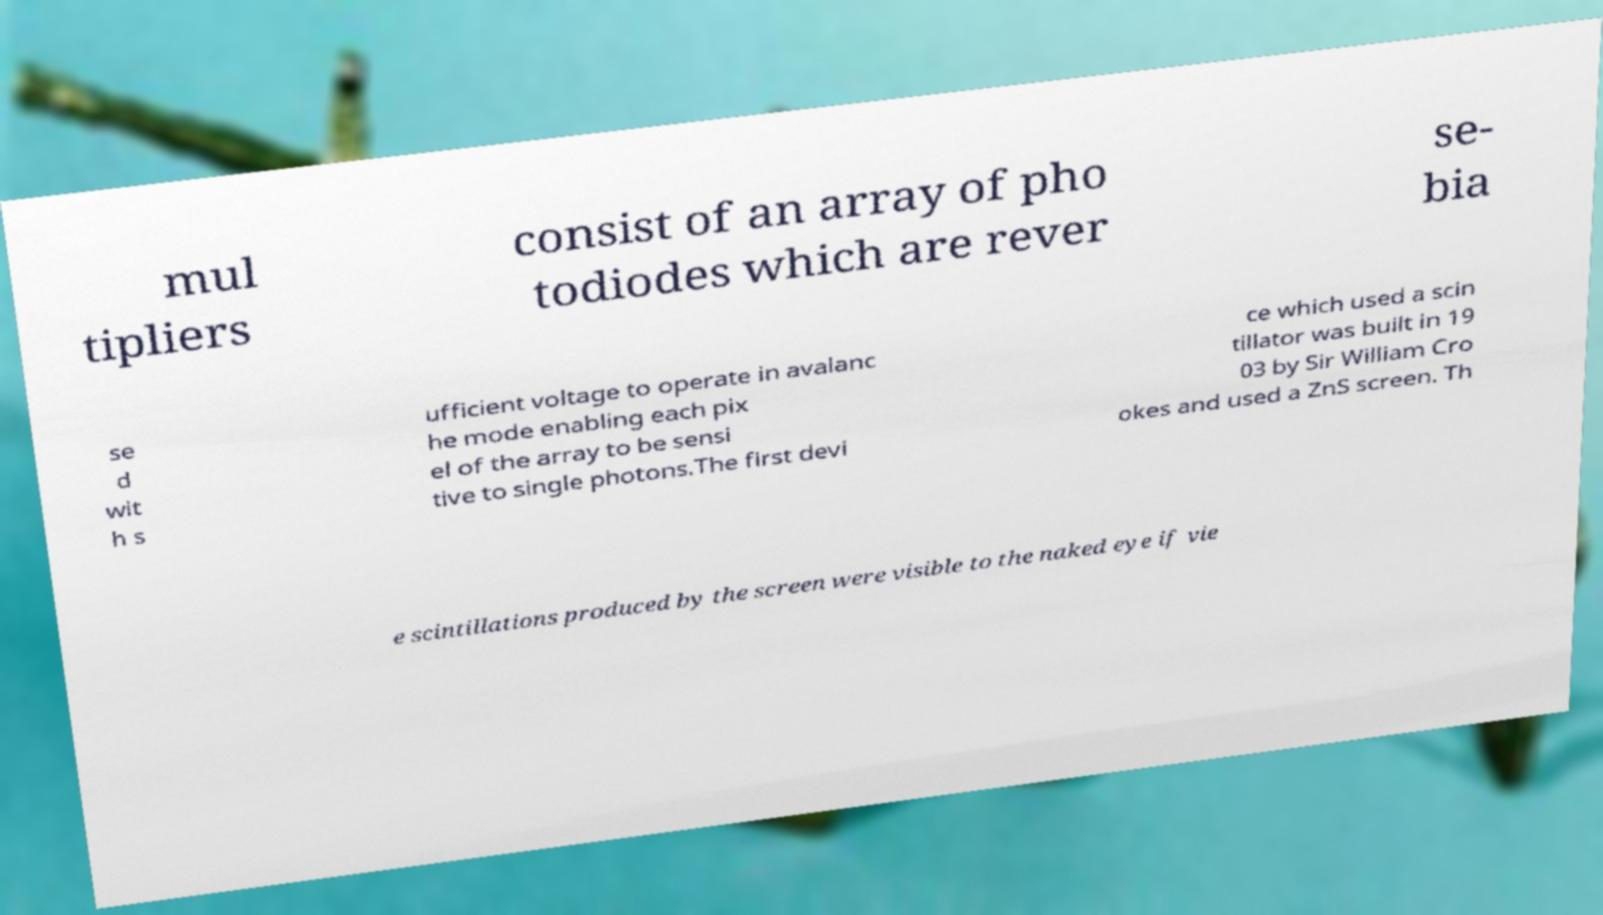Could you extract and type out the text from this image? mul tipliers consist of an array of pho todiodes which are rever se- bia se d wit h s ufficient voltage to operate in avalanc he mode enabling each pix el of the array to be sensi tive to single photons.The first devi ce which used a scin tillator was built in 19 03 by Sir William Cro okes and used a ZnS screen. Th e scintillations produced by the screen were visible to the naked eye if vie 